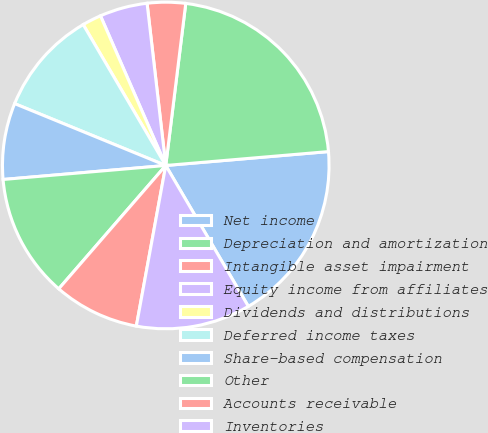<chart> <loc_0><loc_0><loc_500><loc_500><pie_chart><fcel>Net income<fcel>Depreciation and amortization<fcel>Intangible asset impairment<fcel>Equity income from affiliates<fcel>Dividends and distributions<fcel>Deferred income taxes<fcel>Share-based compensation<fcel>Other<fcel>Accounts receivable<fcel>Inventories<nl><fcel>17.92%<fcel>21.69%<fcel>3.78%<fcel>4.72%<fcel>1.89%<fcel>10.38%<fcel>7.55%<fcel>12.26%<fcel>8.49%<fcel>11.32%<nl></chart> 